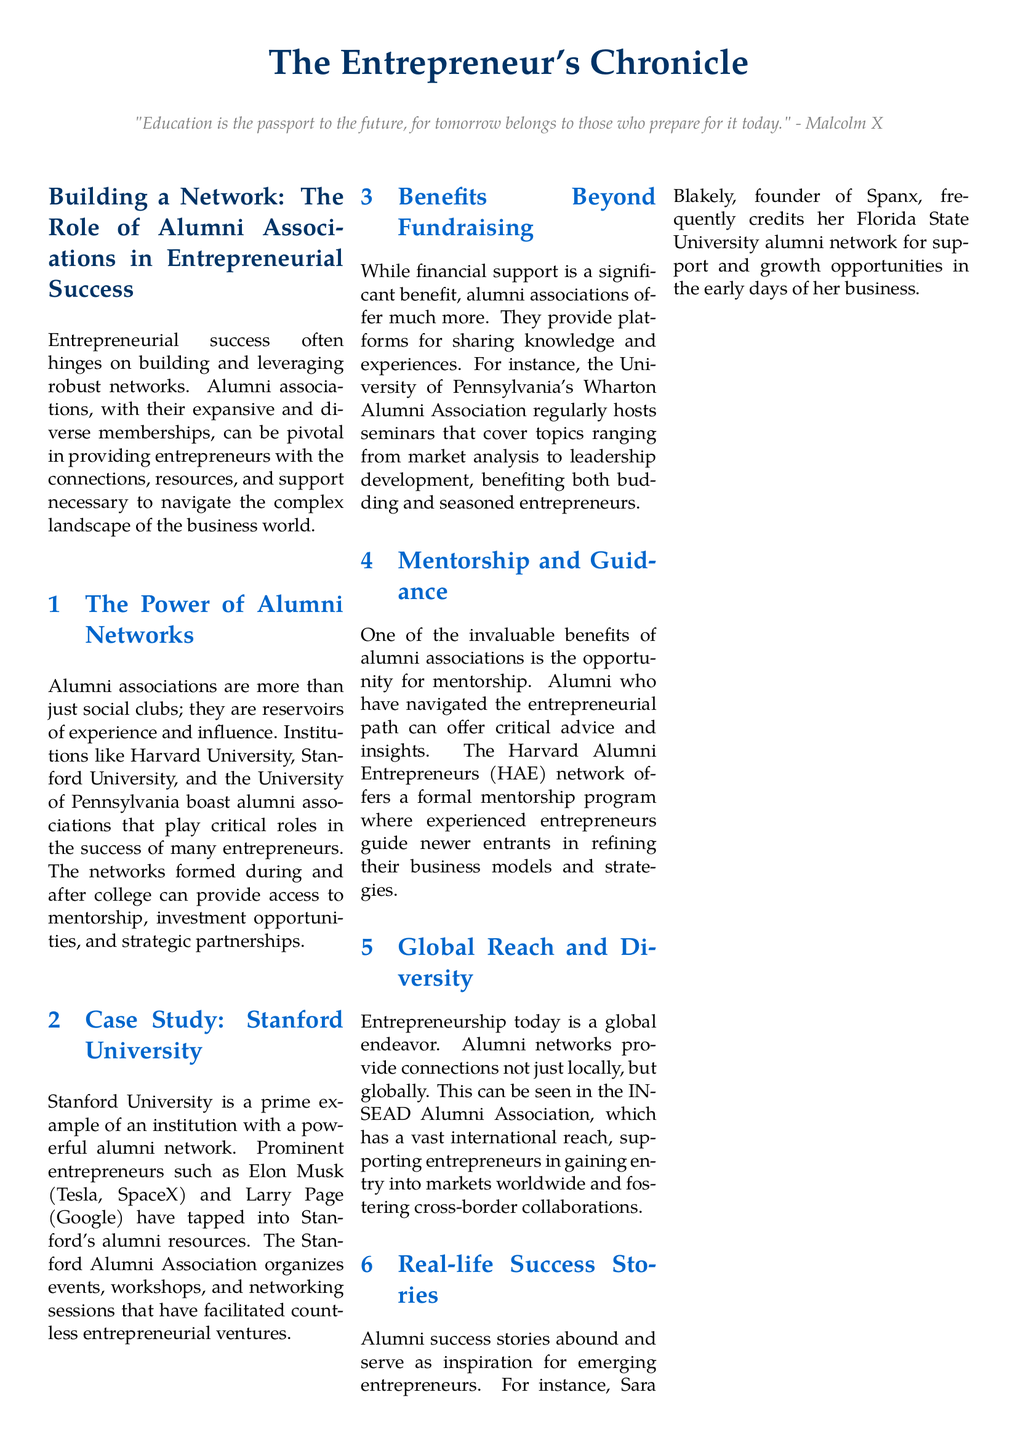What is the title of the article? The title is the main heading of the article, which is given at the beginning of the document.
Answer: Building a Network: The Role of Alumni Associations in Entrepreneurial Success Which university is mentioned as having a powerful alumni network? This is a specific example given in the document to illustrate the role of alumni networks in entrepreneurship.
Answer: Stanford University Who is the founder of Spanx? The document provides a real-life success story about an entrepreneur and their educational background.
Answer: Sara Blakely What does HAE stand for? This abbreviation is mentioned in the context of a mentorship program provided by alumni associations.
Answer: Harvard Alumni Entrepreneurs What is the primary benefit of alumni associations mentioned in the document? The document lists various advantages and this one captures the essence of the support provided.
Answer: Mentorship How does Stanford University support its alumni network? This is described in the article, highlighting the activities that facilitate connections.
Answer: Events, workshops, and networking sessions What institution hosts seminars covering market analysis? The document specifies an alumni association known for educational events relevant to entrepreneurship.
Answer: University of Pennsylvania's Wharton Alumni Association What quote is attributed to Malcolm X? This quote is presented at the beginning of the document to emphasize the importance of education.
Answer: "Education is the passport to the future, for tomorrow belongs to those who prepare for it today." 